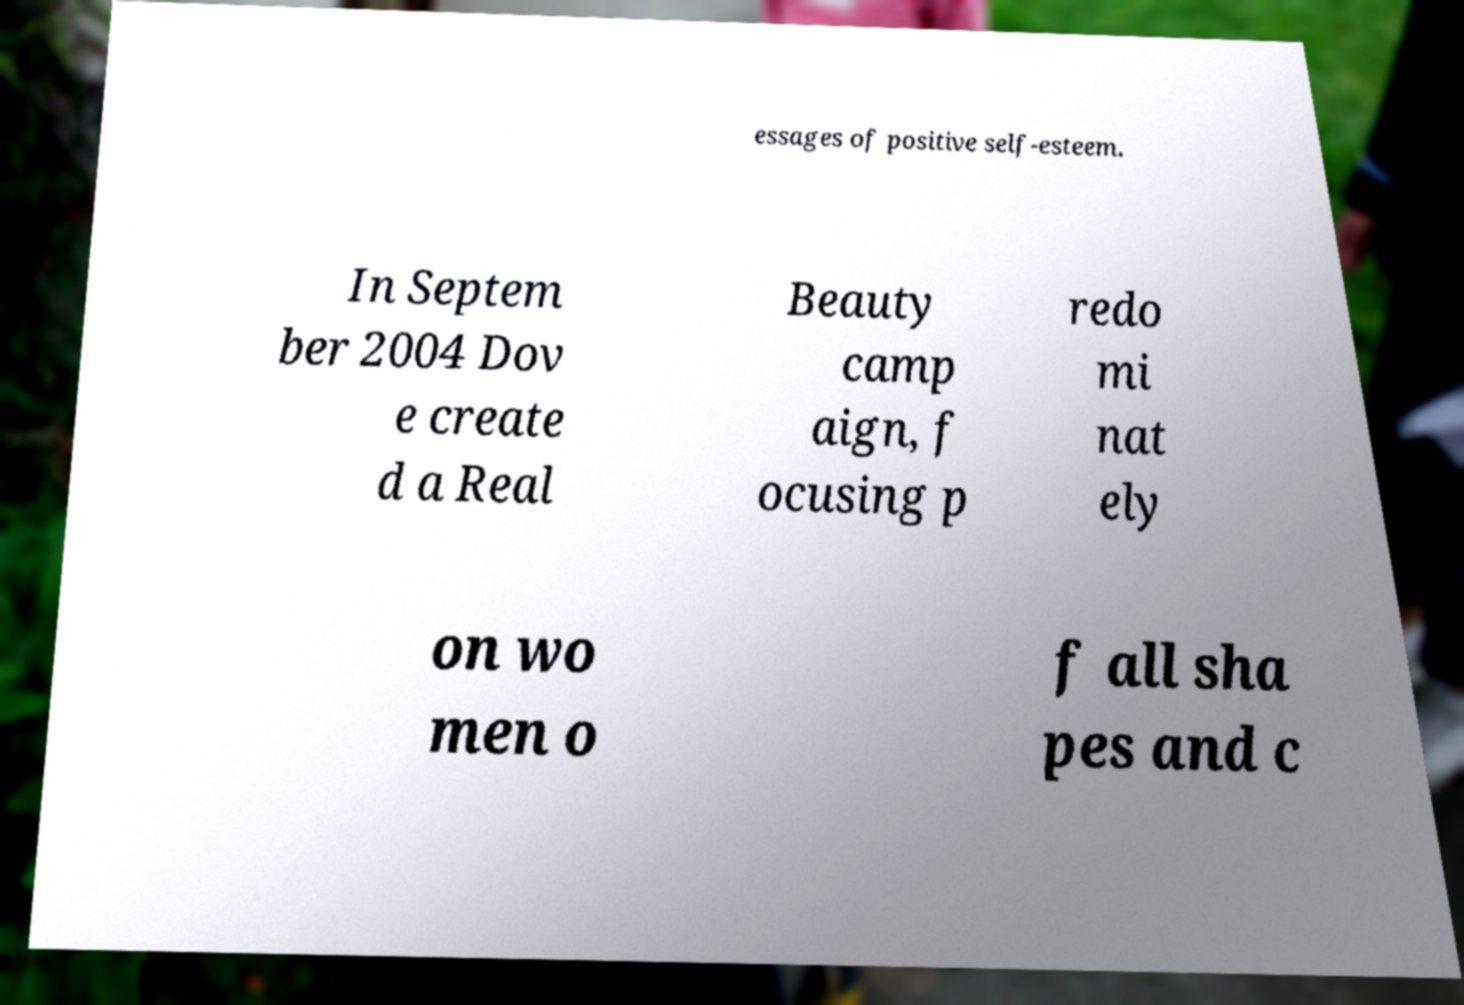For documentation purposes, I need the text within this image transcribed. Could you provide that? essages of positive self-esteem. In Septem ber 2004 Dov e create d a Real Beauty camp aign, f ocusing p redo mi nat ely on wo men o f all sha pes and c 